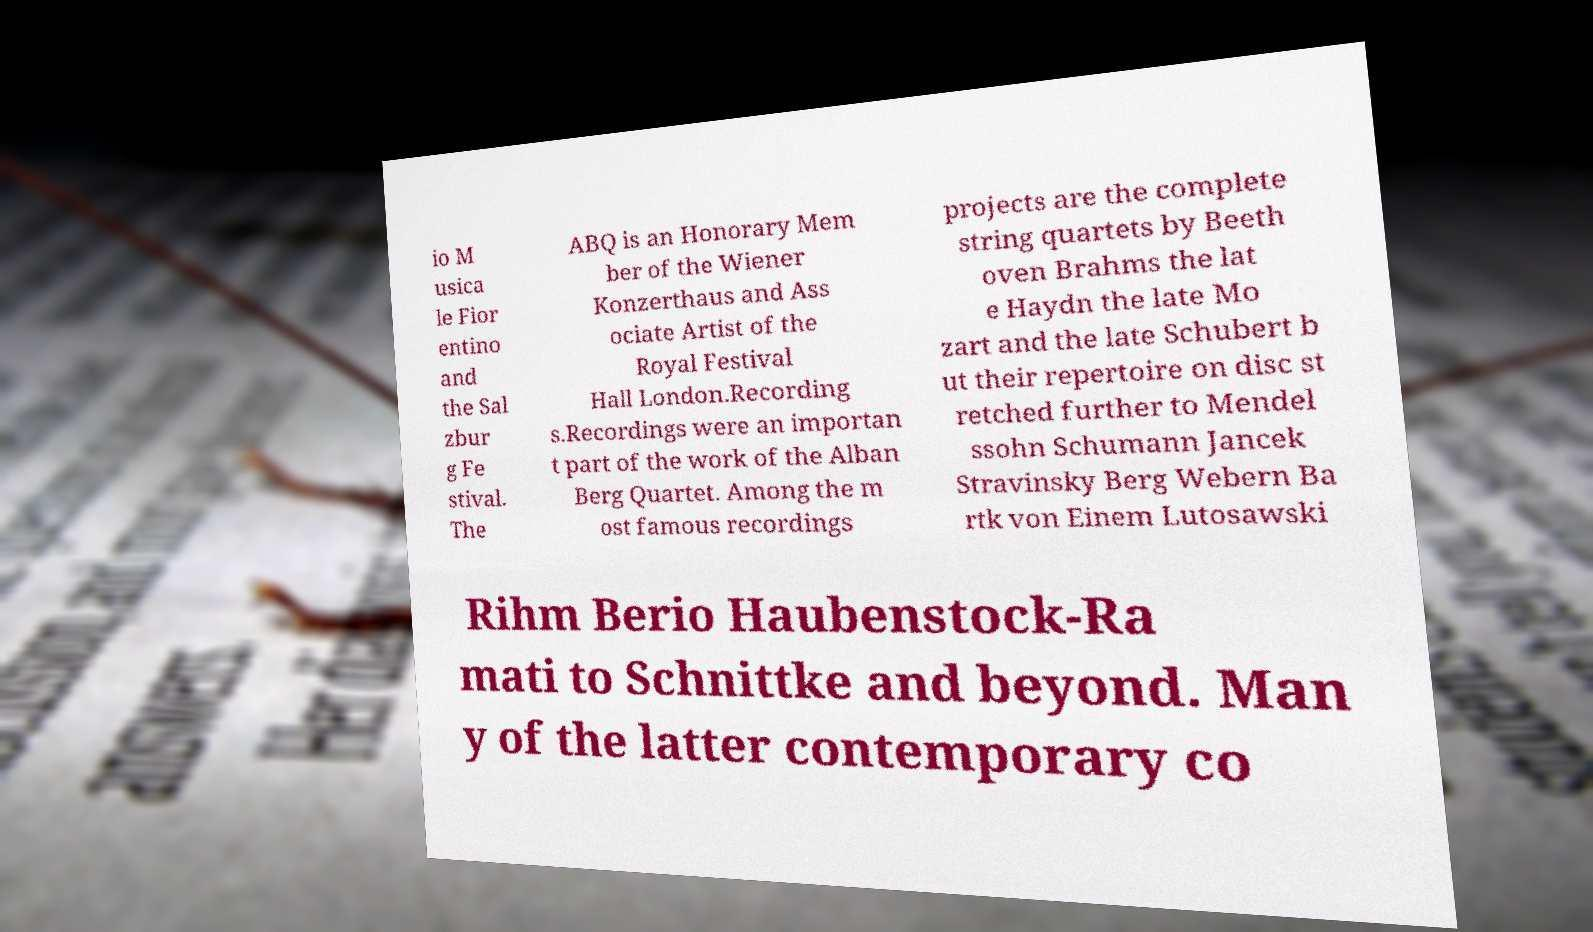Could you extract and type out the text from this image? io M usica le Fior entino and the Sal zbur g Fe stival. The ABQ is an Honorary Mem ber of the Wiener Konzerthaus and Ass ociate Artist of the Royal Festival Hall London.Recording s.Recordings were an importan t part of the work of the Alban Berg Quartet. Among the m ost famous recordings projects are the complete string quartets by Beeth oven Brahms the lat e Haydn the late Mo zart and the late Schubert b ut their repertoire on disc st retched further to Mendel ssohn Schumann Jancek Stravinsky Berg Webern Ba rtk von Einem Lutosawski Rihm Berio Haubenstock-Ra mati to Schnittke and beyond. Man y of the latter contemporary co 